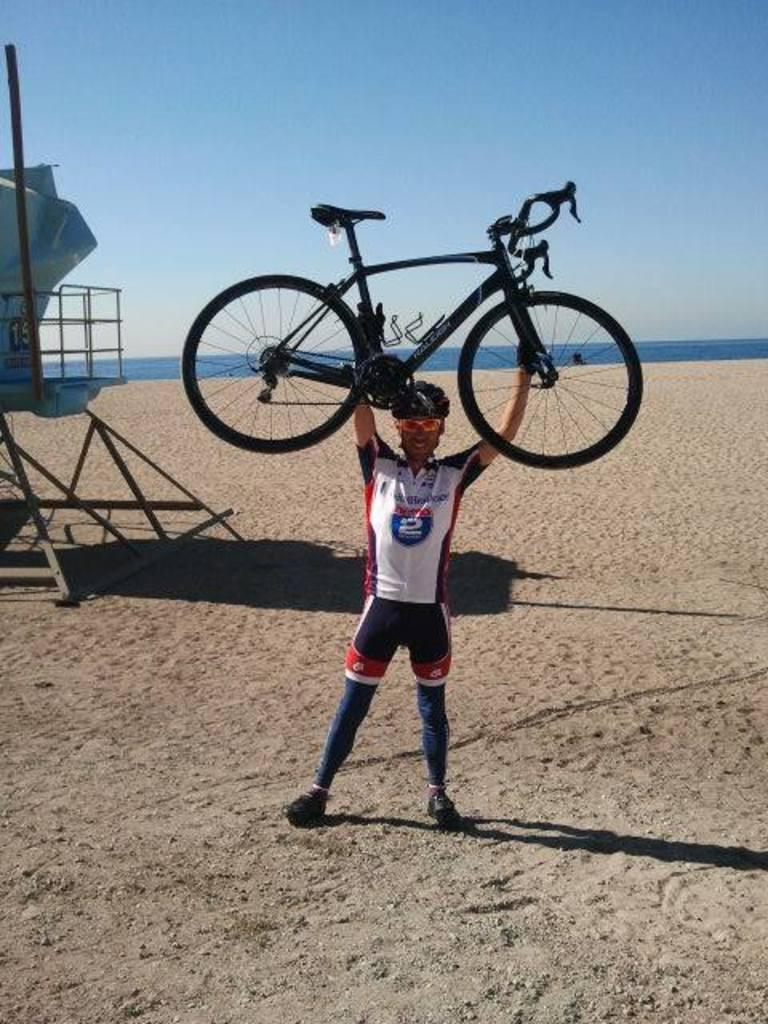<image>
Write a terse but informative summary of the picture. A man wearing a shirt with an Interstate 2 logo holding a bicycle over his head. 